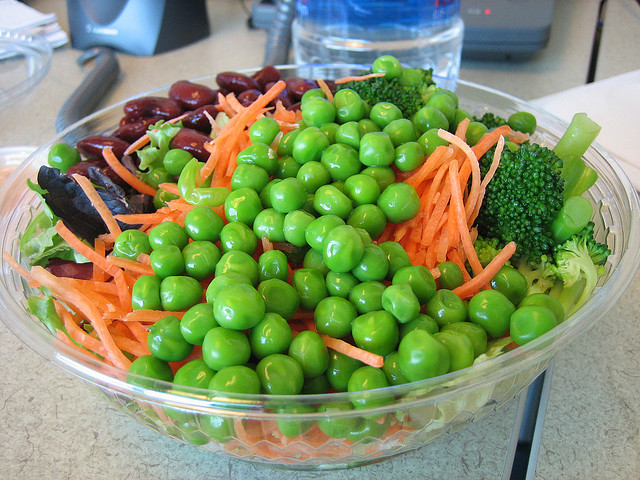This bowl looks really healthy, can you give me an idea of the nutritional benefits of eating salads like this one? Certainly! Salads like the one pictured are packed with nutrients. Green peas are a good source of plant-based protein and fiber. Carrots are rich in beta-carotene, which is important for eye health. Broccoli offers vitamins C and K, and red beans provide both protein and fiber, which can be beneficial for digestive health. Overall, this salad is an excellent choice for a nutrient-dense, low-calorie meal. Could you suggest some other ingredients that might go well with this salad to make it a complete meal? To make this salad an even more complete meal, you might consider adding a source of whole grains, like quinoa or brown rice. Additionally, including a lean protein such as grilled chicken, tofu, or salmon would enhance satiety and nutritional balance. For an extra punch of flavor and healthy fats, tossing in some avocado or a handful of nuts could do the trick. And don't forget a zesty vinaigrette or lemon juice to bring all the flavors together! 